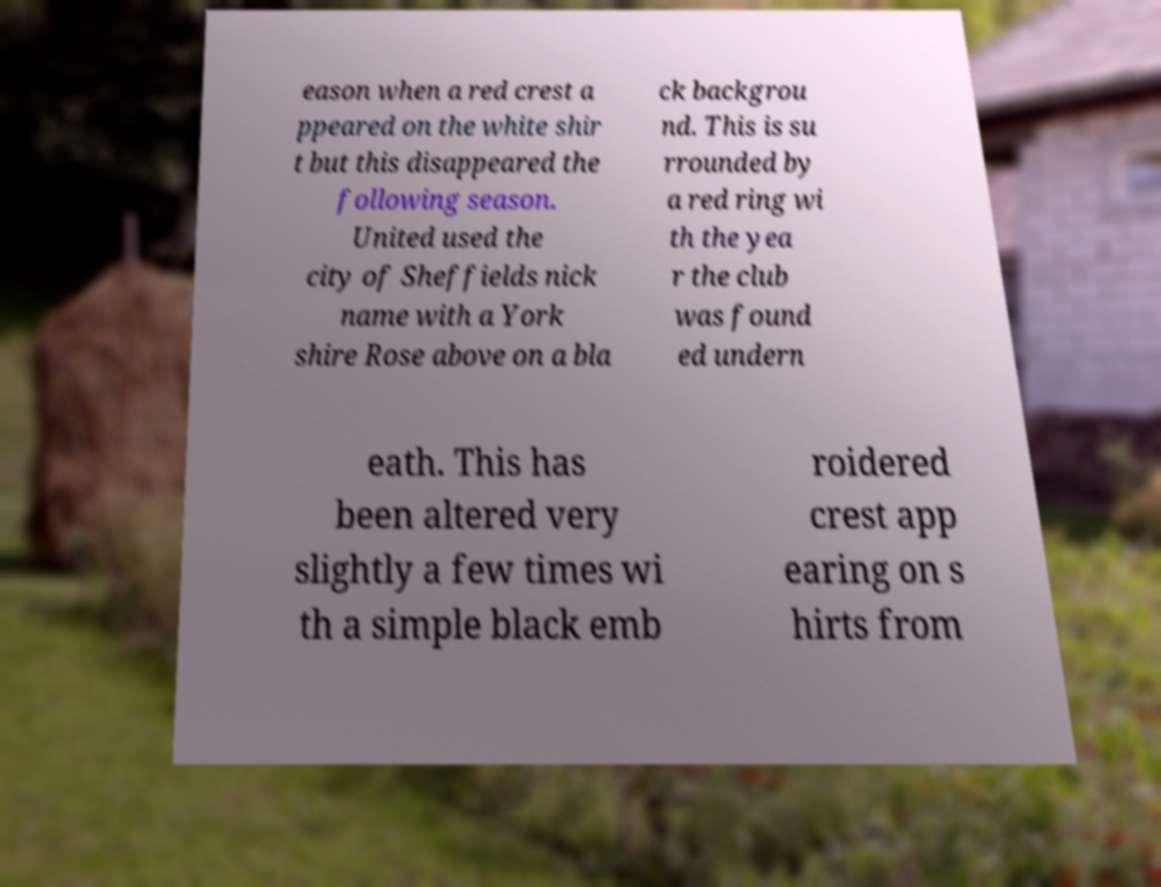Can you read and provide the text displayed in the image?This photo seems to have some interesting text. Can you extract and type it out for me? eason when a red crest a ppeared on the white shir t but this disappeared the following season. United used the city of Sheffields nick name with a York shire Rose above on a bla ck backgrou nd. This is su rrounded by a red ring wi th the yea r the club was found ed undern eath. This has been altered very slightly a few times wi th a simple black emb roidered crest app earing on s hirts from 